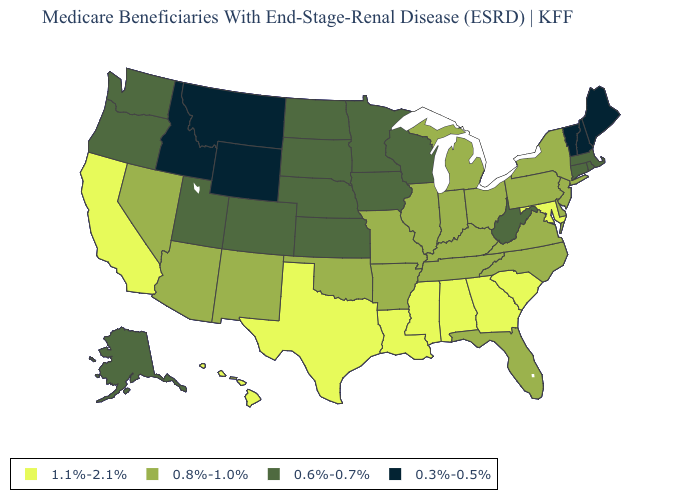What is the value of Washington?
Give a very brief answer. 0.6%-0.7%. Among the states that border Alabama , which have the lowest value?
Give a very brief answer. Florida, Tennessee. Name the states that have a value in the range 0.6%-0.7%?
Concise answer only. Alaska, Colorado, Connecticut, Iowa, Kansas, Massachusetts, Minnesota, Nebraska, North Dakota, Oregon, Rhode Island, South Dakota, Utah, Washington, West Virginia, Wisconsin. What is the value of Arizona?
Give a very brief answer. 0.8%-1.0%. What is the lowest value in the MidWest?
Concise answer only. 0.6%-0.7%. Name the states that have a value in the range 1.1%-2.1%?
Short answer required. Alabama, California, Georgia, Hawaii, Louisiana, Maryland, Mississippi, South Carolina, Texas. Name the states that have a value in the range 0.3%-0.5%?
Concise answer only. Idaho, Maine, Montana, New Hampshire, Vermont, Wyoming. Name the states that have a value in the range 0.8%-1.0%?
Quick response, please. Arizona, Arkansas, Delaware, Florida, Illinois, Indiana, Kentucky, Michigan, Missouri, Nevada, New Jersey, New Mexico, New York, North Carolina, Ohio, Oklahoma, Pennsylvania, Tennessee, Virginia. How many symbols are there in the legend?
Quick response, please. 4. Name the states that have a value in the range 0.8%-1.0%?
Answer briefly. Arizona, Arkansas, Delaware, Florida, Illinois, Indiana, Kentucky, Michigan, Missouri, Nevada, New Jersey, New Mexico, New York, North Carolina, Ohio, Oklahoma, Pennsylvania, Tennessee, Virginia. What is the highest value in states that border Mississippi?
Be succinct. 1.1%-2.1%. What is the value of Virginia?
Write a very short answer. 0.8%-1.0%. Does Montana have the lowest value in the West?
Concise answer only. Yes. Among the states that border California , which have the highest value?
Short answer required. Arizona, Nevada. Name the states that have a value in the range 0.8%-1.0%?
Short answer required. Arizona, Arkansas, Delaware, Florida, Illinois, Indiana, Kentucky, Michigan, Missouri, Nevada, New Jersey, New Mexico, New York, North Carolina, Ohio, Oklahoma, Pennsylvania, Tennessee, Virginia. 